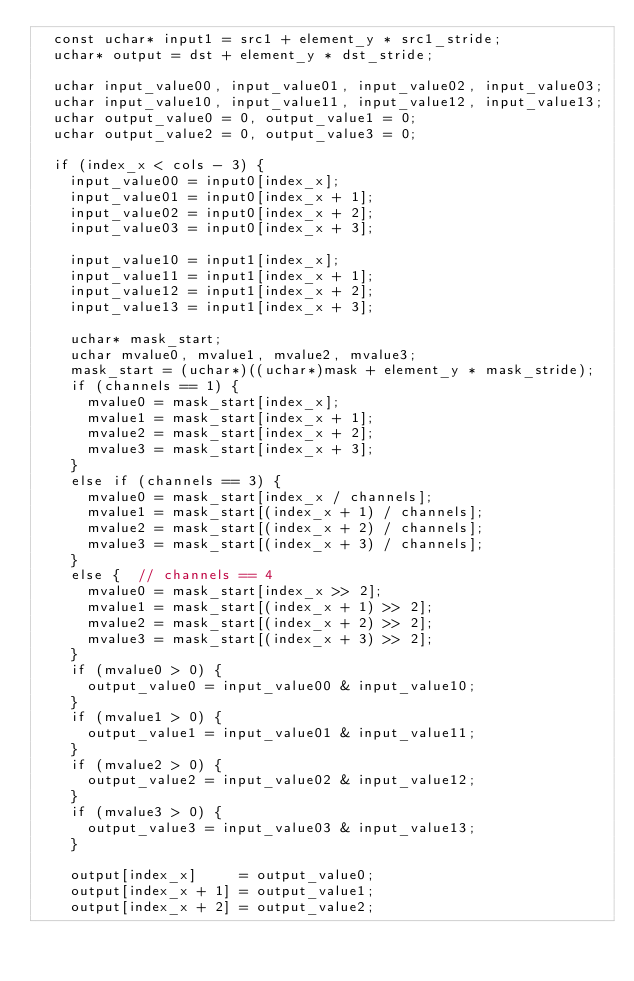<code> <loc_0><loc_0><loc_500><loc_500><_Cuda_>  const uchar* input1 = src1 + element_y * src1_stride;
  uchar* output = dst + element_y * dst_stride;

  uchar input_value00, input_value01, input_value02, input_value03;
  uchar input_value10, input_value11, input_value12, input_value13;
  uchar output_value0 = 0, output_value1 = 0;
  uchar output_value2 = 0, output_value3 = 0;

  if (index_x < cols - 3) {
    input_value00 = input0[index_x];
    input_value01 = input0[index_x + 1];
    input_value02 = input0[index_x + 2];
    input_value03 = input0[index_x + 3];

    input_value10 = input1[index_x];
    input_value11 = input1[index_x + 1];
    input_value12 = input1[index_x + 2];
    input_value13 = input1[index_x + 3];

    uchar* mask_start;
    uchar mvalue0, mvalue1, mvalue2, mvalue3;
    mask_start = (uchar*)((uchar*)mask + element_y * mask_stride);
    if (channels == 1) {
      mvalue0 = mask_start[index_x];
      mvalue1 = mask_start[index_x + 1];
      mvalue2 = mask_start[index_x + 2];
      mvalue3 = mask_start[index_x + 3];
    }
    else if (channels == 3) {
      mvalue0 = mask_start[index_x / channels];
      mvalue1 = mask_start[(index_x + 1) / channels];
      mvalue2 = mask_start[(index_x + 2) / channels];
      mvalue3 = mask_start[(index_x + 3) / channels];
    }
    else {  // channels == 4
      mvalue0 = mask_start[index_x >> 2];
      mvalue1 = mask_start[(index_x + 1) >> 2];
      mvalue2 = mask_start[(index_x + 2) >> 2];
      mvalue3 = mask_start[(index_x + 3) >> 2];
    }
    if (mvalue0 > 0) {
      output_value0 = input_value00 & input_value10;
    }
    if (mvalue1 > 0) {
      output_value1 = input_value01 & input_value11;
    }
    if (mvalue2 > 0) {
      output_value2 = input_value02 & input_value12;
    }
    if (mvalue3 > 0) {
      output_value3 = input_value03 & input_value13;
    }

    output[index_x]     = output_value0;
    output[index_x + 1] = output_value1;
    output[index_x + 2] = output_value2;</code> 